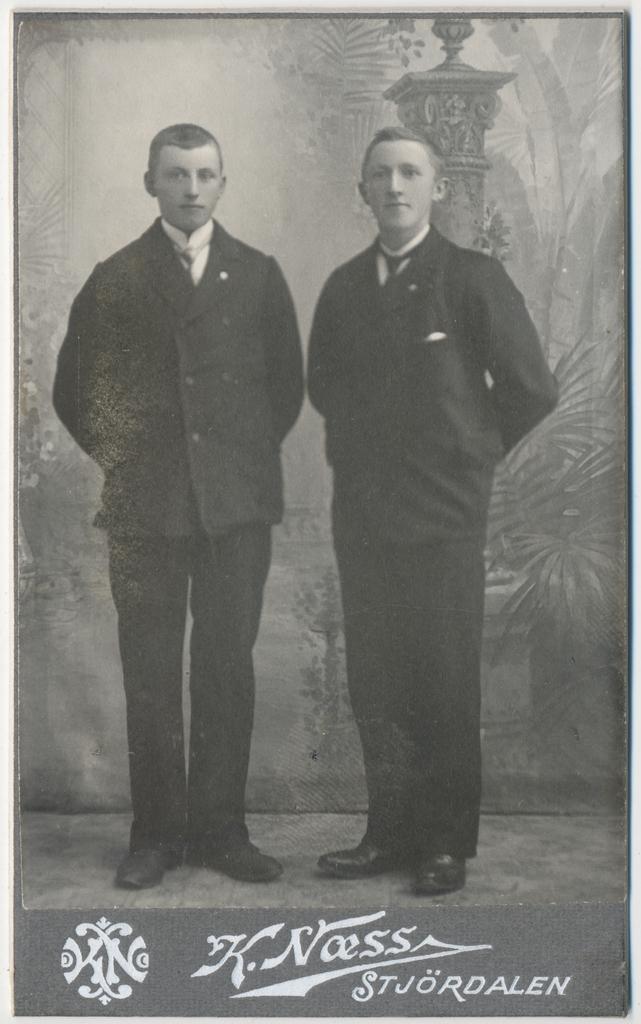Could you give a brief overview of what you see in this image? In this image there are two persons standing , and in the background there is a wall poster, and a watermark on the image. 